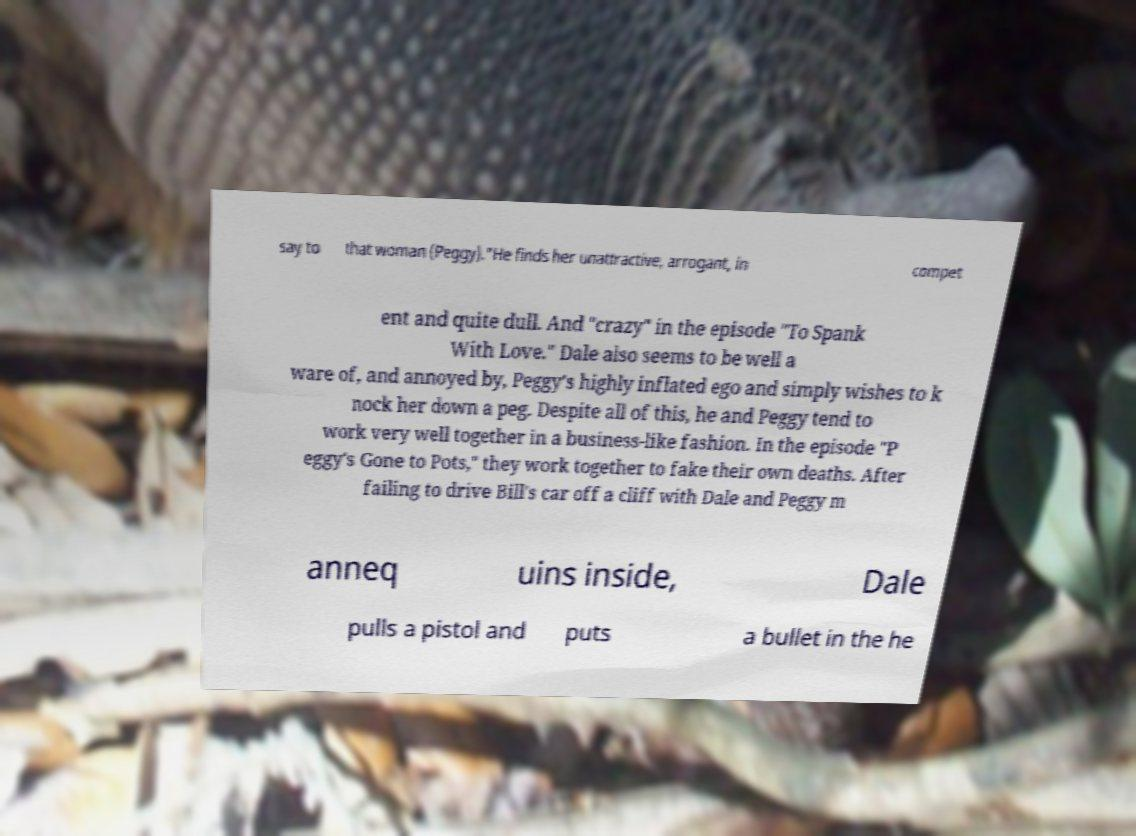What messages or text are displayed in this image? I need them in a readable, typed format. say to that woman (Peggy)."He finds her unattractive, arrogant, in compet ent and quite dull. And "crazy" in the episode "To Spank With Love." Dale also seems to be well a ware of, and annoyed by, Peggy's highly inflated ego and simply wishes to k nock her down a peg. Despite all of this, he and Peggy tend to work very well together in a business-like fashion. In the episode "P eggy's Gone to Pots," they work together to fake their own deaths. After failing to drive Bill's car off a cliff with Dale and Peggy m anneq uins inside, Dale pulls a pistol and puts a bullet in the he 